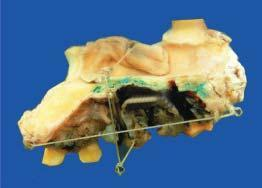does the lumen show an elevated blackish ulcerated area with irregular outlines?
Answer the question using a single word or phrase. No 